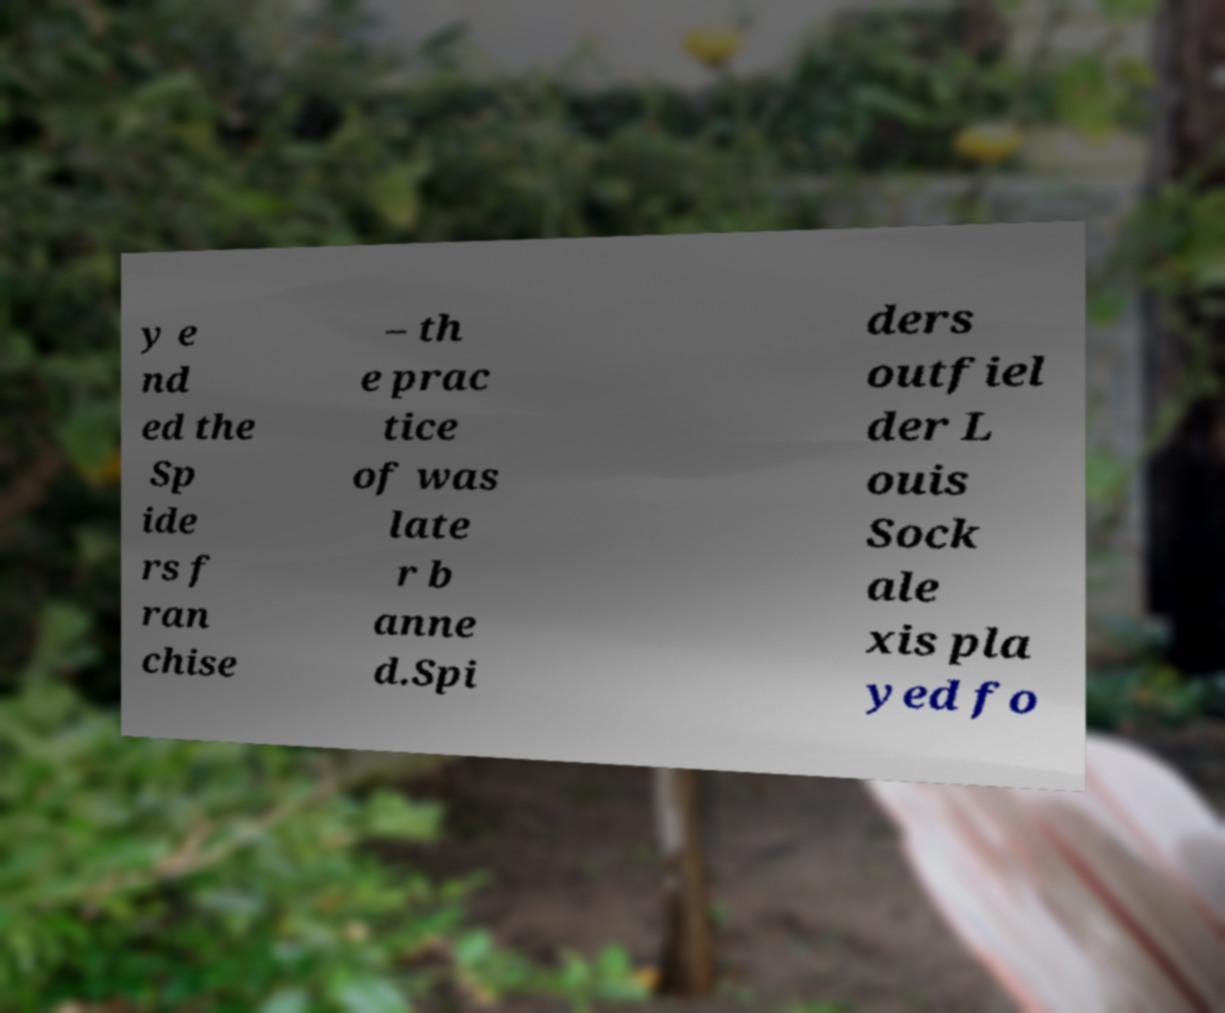What messages or text are displayed in this image? I need them in a readable, typed format. y e nd ed the Sp ide rs f ran chise – th e prac tice of was late r b anne d.Spi ders outfiel der L ouis Sock ale xis pla yed fo 